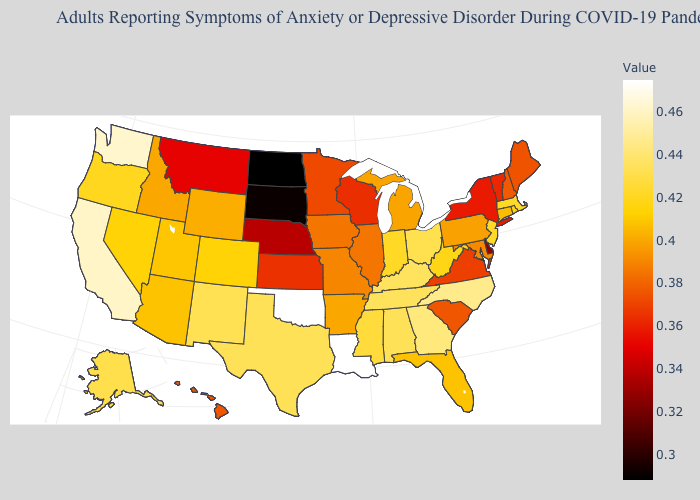Which states have the highest value in the USA?
Short answer required. Louisiana, Oklahoma. Among the states that border Indiana , which have the highest value?
Write a very short answer. Kentucky. Which states have the highest value in the USA?
Short answer required. Louisiana, Oklahoma. Does Oregon have a lower value than Georgia?
Give a very brief answer. Yes. 